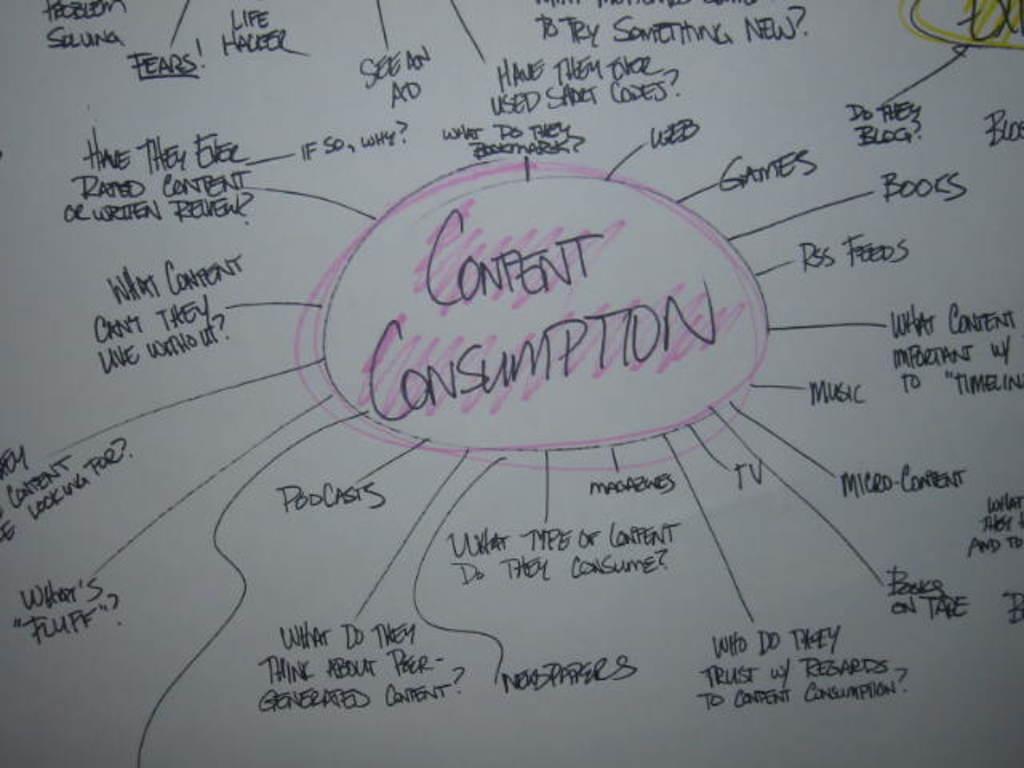What question is asked on the bottom left?
Make the answer very short. Where's. 